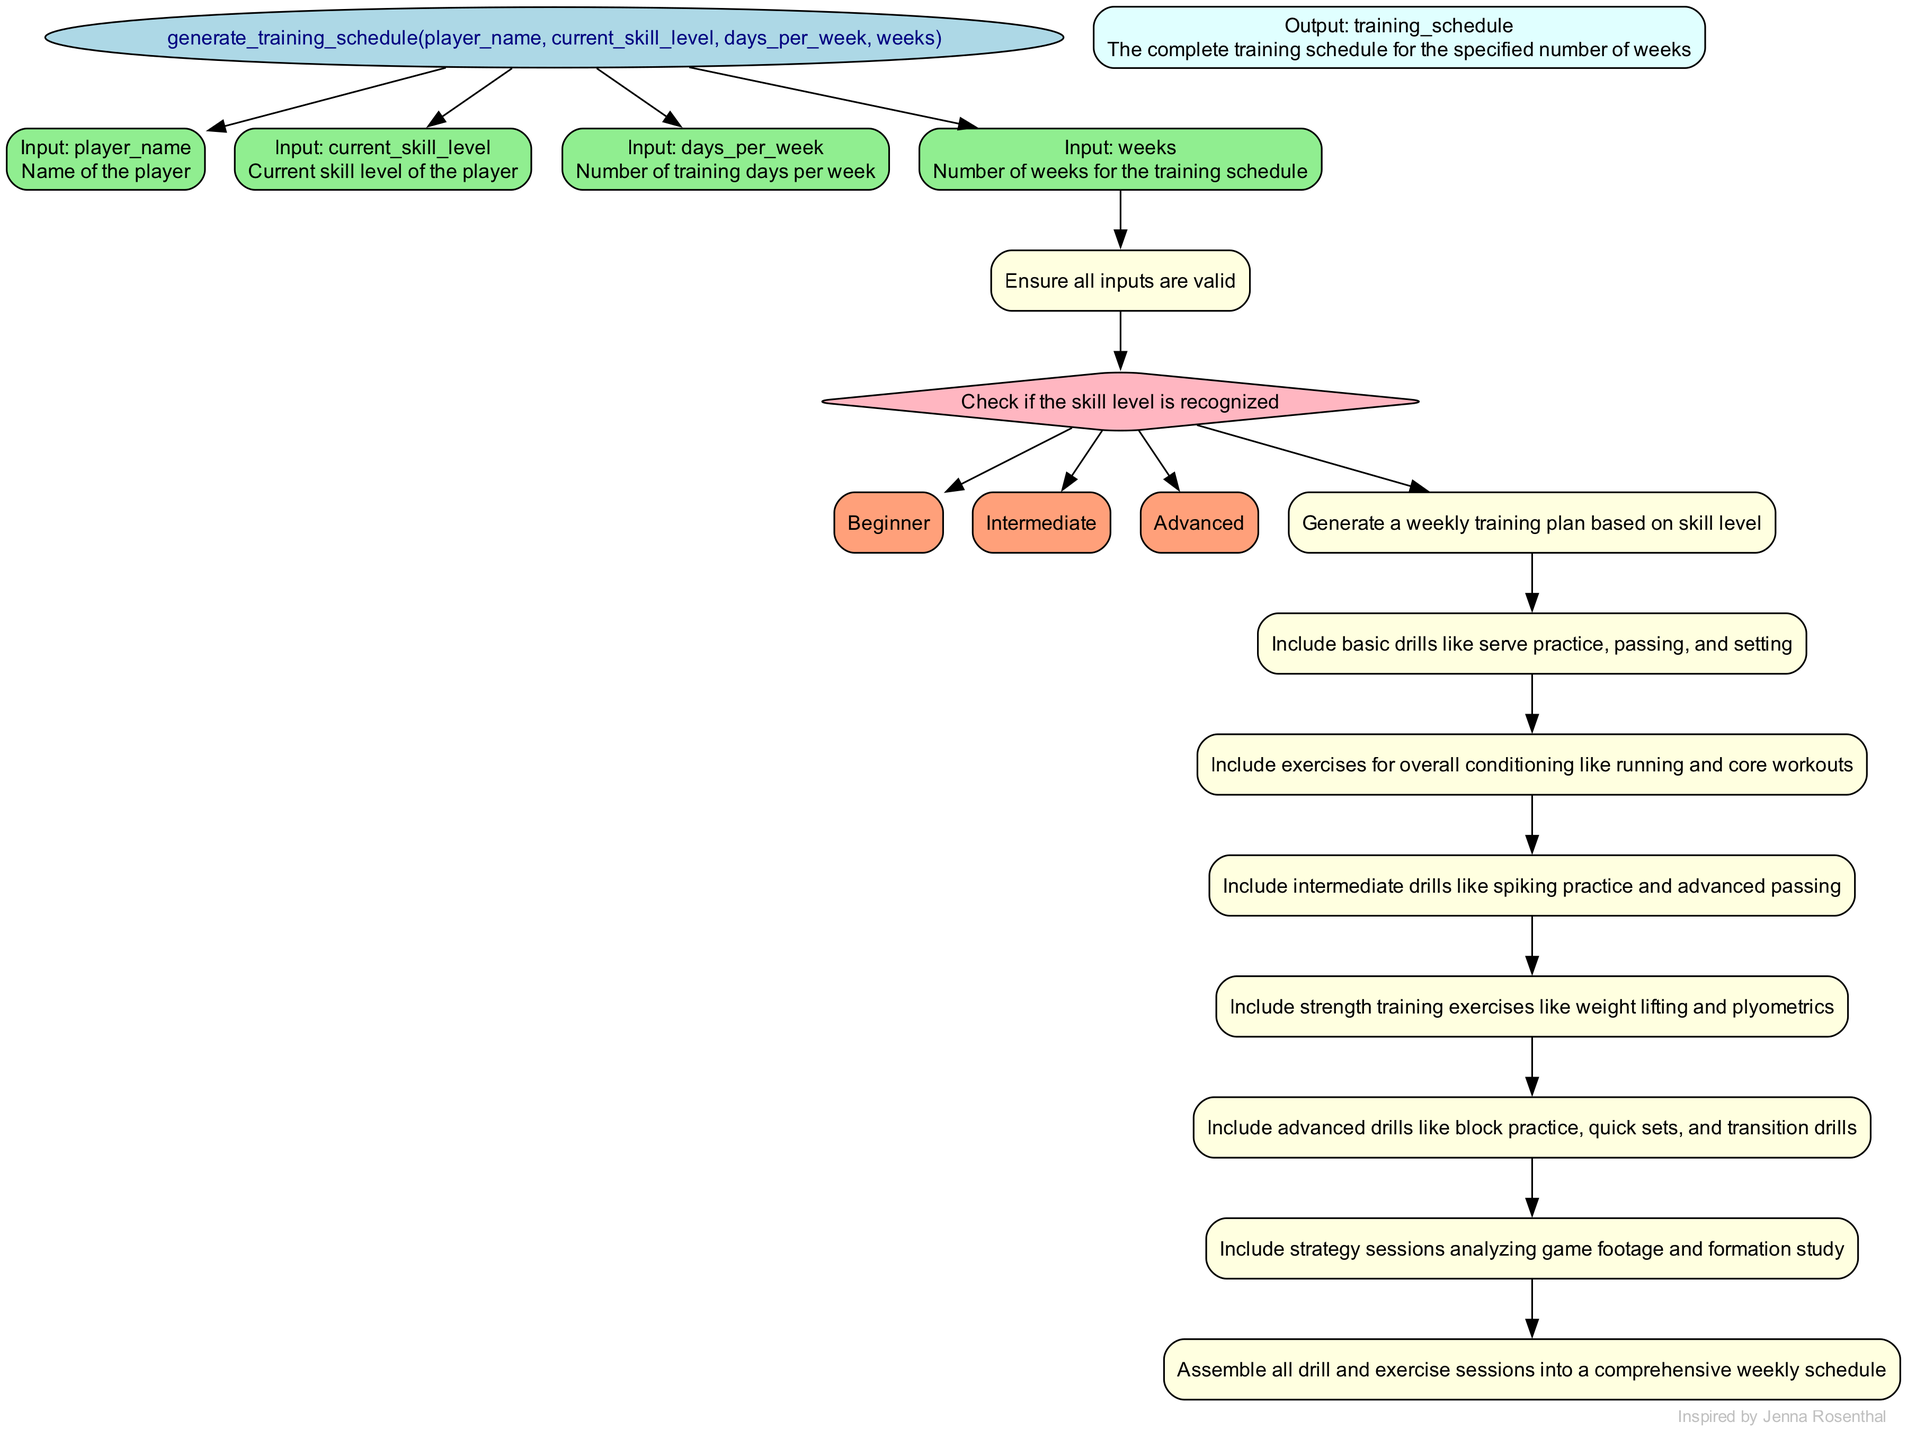What is the first input parameter for the function? The first input parameter listed in the diagram is "player_name," as it is the first element under the function's inputs.
Answer: player_name How many branches are there in the decision node for skill level? The decision node "is_skill_level_appropriate" has three branches that represent different skill levels: beginner, intermediate, and advanced.
Answer: 3 What does the "create_weekly_plan" process generate based on skill level? The "create_weekly_plan" process generates a weekly training plan specifically tailored to the player's skill level, which can include different drills and exercises.
Answer: Weekly training plan What type of drills are included in the "intermediate_drills" process? The "intermediate_drills" process includes drills that are specifically designed for players at an intermediate level, such as spiking practice and advanced passing.
Answer: Spiking practice and advanced passing Which process leads to the final output of the training schedule? The process that leads to the final output of the training schedule is "assemble_schedule." This process compiles all previous sessions into a comprehensive schedule.
Answer: assemble_schedule What is the output of the function when completed? The output of the function is described as the training schedule that covers the specified number of weeks, detailing the drills and exercises.
Answer: The complete training schedule What does the "strength_training" process include? The "strength_training" process includes exercises that specifically focus on increasing strength, such as weight lifting and plyometrics.
Answer: Weight lifting and plyometrics If a player's skill level is advanced, what are the types of sessions included in their weekly plan? If a player's skill level is advanced, their weekly plan will include advanced drills like block practice, quick sets, and transition drills, alongside strategy sessions that involve game analysis.
Answer: Block practice, quick sets, and transition drills What are the two main types of exercises included for a beginner in the training schedule? For a beginner in the training schedule, the two main types of exercises included are basic drills and conditioning exercises.
Answer: Basic drills and conditioning exercises 